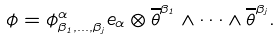Convert formula to latex. <formula><loc_0><loc_0><loc_500><loc_500>\phi = \phi ^ { \alpha } _ { \beta _ { 1 } , \dots , \beta _ { j } } e _ { \alpha } \otimes \overline { \theta } ^ { \beta _ { 1 } } \wedge \cdots \wedge \overline { \theta } ^ { \beta _ { j } } .</formula> 